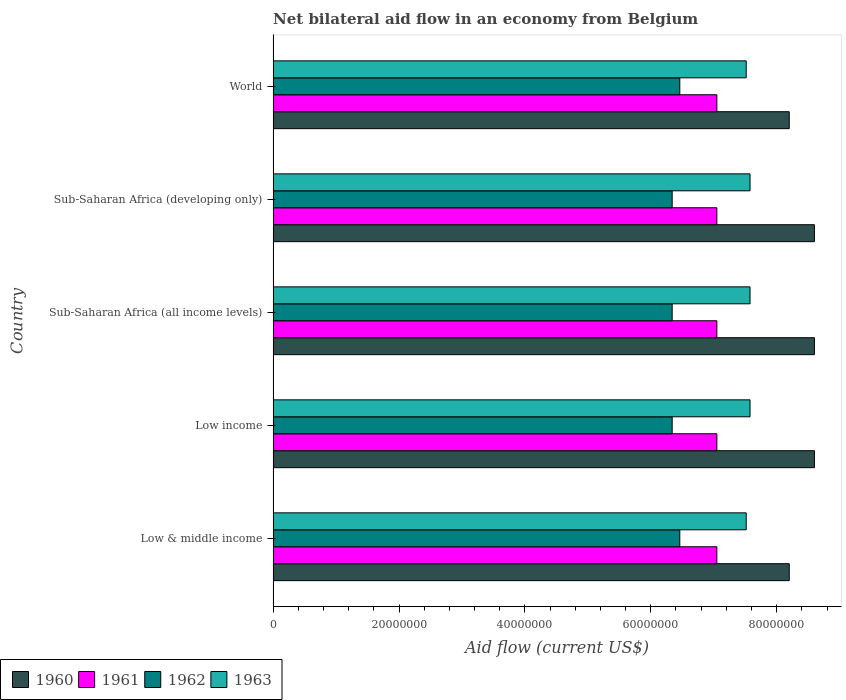How many different coloured bars are there?
Keep it short and to the point. 4. How many groups of bars are there?
Provide a short and direct response. 5. Are the number of bars on each tick of the Y-axis equal?
Give a very brief answer. Yes. How many bars are there on the 2nd tick from the top?
Offer a very short reply. 4. What is the label of the 4th group of bars from the top?
Provide a short and direct response. Low income. In how many cases, is the number of bars for a given country not equal to the number of legend labels?
Provide a succinct answer. 0. What is the net bilateral aid flow in 1960 in Sub-Saharan Africa (all income levels)?
Offer a very short reply. 8.60e+07. Across all countries, what is the maximum net bilateral aid flow in 1962?
Offer a terse response. 6.46e+07. Across all countries, what is the minimum net bilateral aid flow in 1963?
Ensure brevity in your answer.  7.52e+07. What is the total net bilateral aid flow in 1963 in the graph?
Offer a very short reply. 3.78e+08. What is the difference between the net bilateral aid flow in 1960 in Low & middle income and that in World?
Keep it short and to the point. 0. What is the difference between the net bilateral aid flow in 1960 in Low income and the net bilateral aid flow in 1961 in Low & middle income?
Offer a terse response. 1.55e+07. What is the average net bilateral aid flow in 1960 per country?
Provide a succinct answer. 8.44e+07. What is the difference between the net bilateral aid flow in 1963 and net bilateral aid flow in 1962 in Sub-Saharan Africa (all income levels)?
Ensure brevity in your answer.  1.24e+07. What is the ratio of the net bilateral aid flow in 1960 in Low & middle income to that in World?
Make the answer very short. 1. What is the difference between the highest and the lowest net bilateral aid flow in 1963?
Offer a terse response. 6.10e+05. In how many countries, is the net bilateral aid flow in 1960 greater than the average net bilateral aid flow in 1960 taken over all countries?
Provide a succinct answer. 3. What does the 2nd bar from the bottom in Low income represents?
Keep it short and to the point. 1961. Is it the case that in every country, the sum of the net bilateral aid flow in 1961 and net bilateral aid flow in 1962 is greater than the net bilateral aid flow in 1963?
Your response must be concise. Yes. How many bars are there?
Offer a terse response. 20. Does the graph contain any zero values?
Offer a very short reply. No. How many legend labels are there?
Give a very brief answer. 4. How are the legend labels stacked?
Keep it short and to the point. Horizontal. What is the title of the graph?
Give a very brief answer. Net bilateral aid flow in an economy from Belgium. What is the Aid flow (current US$) of 1960 in Low & middle income?
Provide a short and direct response. 8.20e+07. What is the Aid flow (current US$) of 1961 in Low & middle income?
Keep it short and to the point. 7.05e+07. What is the Aid flow (current US$) of 1962 in Low & middle income?
Your answer should be compact. 6.46e+07. What is the Aid flow (current US$) of 1963 in Low & middle income?
Offer a very short reply. 7.52e+07. What is the Aid flow (current US$) of 1960 in Low income?
Your answer should be very brief. 8.60e+07. What is the Aid flow (current US$) in 1961 in Low income?
Ensure brevity in your answer.  7.05e+07. What is the Aid flow (current US$) in 1962 in Low income?
Ensure brevity in your answer.  6.34e+07. What is the Aid flow (current US$) of 1963 in Low income?
Provide a short and direct response. 7.58e+07. What is the Aid flow (current US$) in 1960 in Sub-Saharan Africa (all income levels)?
Offer a very short reply. 8.60e+07. What is the Aid flow (current US$) in 1961 in Sub-Saharan Africa (all income levels)?
Your answer should be compact. 7.05e+07. What is the Aid flow (current US$) of 1962 in Sub-Saharan Africa (all income levels)?
Provide a short and direct response. 6.34e+07. What is the Aid flow (current US$) of 1963 in Sub-Saharan Africa (all income levels)?
Make the answer very short. 7.58e+07. What is the Aid flow (current US$) of 1960 in Sub-Saharan Africa (developing only)?
Give a very brief answer. 8.60e+07. What is the Aid flow (current US$) of 1961 in Sub-Saharan Africa (developing only)?
Offer a terse response. 7.05e+07. What is the Aid flow (current US$) in 1962 in Sub-Saharan Africa (developing only)?
Offer a terse response. 6.34e+07. What is the Aid flow (current US$) of 1963 in Sub-Saharan Africa (developing only)?
Ensure brevity in your answer.  7.58e+07. What is the Aid flow (current US$) of 1960 in World?
Offer a very short reply. 8.20e+07. What is the Aid flow (current US$) in 1961 in World?
Make the answer very short. 7.05e+07. What is the Aid flow (current US$) of 1962 in World?
Your answer should be very brief. 6.46e+07. What is the Aid flow (current US$) in 1963 in World?
Your answer should be compact. 7.52e+07. Across all countries, what is the maximum Aid flow (current US$) of 1960?
Your answer should be very brief. 8.60e+07. Across all countries, what is the maximum Aid flow (current US$) of 1961?
Provide a short and direct response. 7.05e+07. Across all countries, what is the maximum Aid flow (current US$) in 1962?
Ensure brevity in your answer.  6.46e+07. Across all countries, what is the maximum Aid flow (current US$) of 1963?
Provide a succinct answer. 7.58e+07. Across all countries, what is the minimum Aid flow (current US$) in 1960?
Make the answer very short. 8.20e+07. Across all countries, what is the minimum Aid flow (current US$) of 1961?
Your answer should be compact. 7.05e+07. Across all countries, what is the minimum Aid flow (current US$) of 1962?
Offer a terse response. 6.34e+07. Across all countries, what is the minimum Aid flow (current US$) of 1963?
Ensure brevity in your answer.  7.52e+07. What is the total Aid flow (current US$) of 1960 in the graph?
Give a very brief answer. 4.22e+08. What is the total Aid flow (current US$) of 1961 in the graph?
Ensure brevity in your answer.  3.52e+08. What is the total Aid flow (current US$) of 1962 in the graph?
Make the answer very short. 3.19e+08. What is the total Aid flow (current US$) of 1963 in the graph?
Offer a very short reply. 3.78e+08. What is the difference between the Aid flow (current US$) in 1960 in Low & middle income and that in Low income?
Provide a succinct answer. -4.00e+06. What is the difference between the Aid flow (current US$) of 1962 in Low & middle income and that in Low income?
Provide a short and direct response. 1.21e+06. What is the difference between the Aid flow (current US$) of 1963 in Low & middle income and that in Low income?
Your response must be concise. -6.10e+05. What is the difference between the Aid flow (current US$) of 1961 in Low & middle income and that in Sub-Saharan Africa (all income levels)?
Provide a succinct answer. 0. What is the difference between the Aid flow (current US$) in 1962 in Low & middle income and that in Sub-Saharan Africa (all income levels)?
Offer a terse response. 1.21e+06. What is the difference between the Aid flow (current US$) in 1963 in Low & middle income and that in Sub-Saharan Africa (all income levels)?
Keep it short and to the point. -6.10e+05. What is the difference between the Aid flow (current US$) in 1960 in Low & middle income and that in Sub-Saharan Africa (developing only)?
Provide a short and direct response. -4.00e+06. What is the difference between the Aid flow (current US$) of 1961 in Low & middle income and that in Sub-Saharan Africa (developing only)?
Your response must be concise. 0. What is the difference between the Aid flow (current US$) of 1962 in Low & middle income and that in Sub-Saharan Africa (developing only)?
Keep it short and to the point. 1.21e+06. What is the difference between the Aid flow (current US$) of 1963 in Low & middle income and that in Sub-Saharan Africa (developing only)?
Provide a short and direct response. -6.10e+05. What is the difference between the Aid flow (current US$) of 1960 in Low & middle income and that in World?
Keep it short and to the point. 0. What is the difference between the Aid flow (current US$) of 1962 in Low & middle income and that in World?
Give a very brief answer. 0. What is the difference between the Aid flow (current US$) in 1961 in Low income and that in Sub-Saharan Africa (all income levels)?
Make the answer very short. 0. What is the difference between the Aid flow (current US$) in 1963 in Low income and that in Sub-Saharan Africa (all income levels)?
Offer a very short reply. 0. What is the difference between the Aid flow (current US$) in 1962 in Low income and that in World?
Provide a short and direct response. -1.21e+06. What is the difference between the Aid flow (current US$) in 1963 in Low income and that in World?
Provide a short and direct response. 6.10e+05. What is the difference between the Aid flow (current US$) of 1960 in Sub-Saharan Africa (all income levels) and that in Sub-Saharan Africa (developing only)?
Your response must be concise. 0. What is the difference between the Aid flow (current US$) in 1961 in Sub-Saharan Africa (all income levels) and that in Sub-Saharan Africa (developing only)?
Offer a very short reply. 0. What is the difference between the Aid flow (current US$) in 1963 in Sub-Saharan Africa (all income levels) and that in Sub-Saharan Africa (developing only)?
Your response must be concise. 0. What is the difference between the Aid flow (current US$) in 1961 in Sub-Saharan Africa (all income levels) and that in World?
Give a very brief answer. 0. What is the difference between the Aid flow (current US$) of 1962 in Sub-Saharan Africa (all income levels) and that in World?
Offer a very short reply. -1.21e+06. What is the difference between the Aid flow (current US$) of 1963 in Sub-Saharan Africa (all income levels) and that in World?
Your answer should be very brief. 6.10e+05. What is the difference between the Aid flow (current US$) in 1962 in Sub-Saharan Africa (developing only) and that in World?
Make the answer very short. -1.21e+06. What is the difference between the Aid flow (current US$) in 1963 in Sub-Saharan Africa (developing only) and that in World?
Provide a short and direct response. 6.10e+05. What is the difference between the Aid flow (current US$) in 1960 in Low & middle income and the Aid flow (current US$) in 1961 in Low income?
Provide a succinct answer. 1.15e+07. What is the difference between the Aid flow (current US$) in 1960 in Low & middle income and the Aid flow (current US$) in 1962 in Low income?
Make the answer very short. 1.86e+07. What is the difference between the Aid flow (current US$) of 1960 in Low & middle income and the Aid flow (current US$) of 1963 in Low income?
Your response must be concise. 6.23e+06. What is the difference between the Aid flow (current US$) in 1961 in Low & middle income and the Aid flow (current US$) in 1962 in Low income?
Your answer should be compact. 7.10e+06. What is the difference between the Aid flow (current US$) of 1961 in Low & middle income and the Aid flow (current US$) of 1963 in Low income?
Offer a very short reply. -5.27e+06. What is the difference between the Aid flow (current US$) in 1962 in Low & middle income and the Aid flow (current US$) in 1963 in Low income?
Your answer should be very brief. -1.12e+07. What is the difference between the Aid flow (current US$) in 1960 in Low & middle income and the Aid flow (current US$) in 1961 in Sub-Saharan Africa (all income levels)?
Give a very brief answer. 1.15e+07. What is the difference between the Aid flow (current US$) in 1960 in Low & middle income and the Aid flow (current US$) in 1962 in Sub-Saharan Africa (all income levels)?
Provide a succinct answer. 1.86e+07. What is the difference between the Aid flow (current US$) in 1960 in Low & middle income and the Aid flow (current US$) in 1963 in Sub-Saharan Africa (all income levels)?
Keep it short and to the point. 6.23e+06. What is the difference between the Aid flow (current US$) in 1961 in Low & middle income and the Aid flow (current US$) in 1962 in Sub-Saharan Africa (all income levels)?
Provide a succinct answer. 7.10e+06. What is the difference between the Aid flow (current US$) of 1961 in Low & middle income and the Aid flow (current US$) of 1963 in Sub-Saharan Africa (all income levels)?
Keep it short and to the point. -5.27e+06. What is the difference between the Aid flow (current US$) in 1962 in Low & middle income and the Aid flow (current US$) in 1963 in Sub-Saharan Africa (all income levels)?
Ensure brevity in your answer.  -1.12e+07. What is the difference between the Aid flow (current US$) of 1960 in Low & middle income and the Aid flow (current US$) of 1961 in Sub-Saharan Africa (developing only)?
Your answer should be compact. 1.15e+07. What is the difference between the Aid flow (current US$) of 1960 in Low & middle income and the Aid flow (current US$) of 1962 in Sub-Saharan Africa (developing only)?
Give a very brief answer. 1.86e+07. What is the difference between the Aid flow (current US$) of 1960 in Low & middle income and the Aid flow (current US$) of 1963 in Sub-Saharan Africa (developing only)?
Keep it short and to the point. 6.23e+06. What is the difference between the Aid flow (current US$) in 1961 in Low & middle income and the Aid flow (current US$) in 1962 in Sub-Saharan Africa (developing only)?
Keep it short and to the point. 7.10e+06. What is the difference between the Aid flow (current US$) in 1961 in Low & middle income and the Aid flow (current US$) in 1963 in Sub-Saharan Africa (developing only)?
Your answer should be compact. -5.27e+06. What is the difference between the Aid flow (current US$) in 1962 in Low & middle income and the Aid flow (current US$) in 1963 in Sub-Saharan Africa (developing only)?
Offer a very short reply. -1.12e+07. What is the difference between the Aid flow (current US$) in 1960 in Low & middle income and the Aid flow (current US$) in 1961 in World?
Provide a short and direct response. 1.15e+07. What is the difference between the Aid flow (current US$) of 1960 in Low & middle income and the Aid flow (current US$) of 1962 in World?
Provide a succinct answer. 1.74e+07. What is the difference between the Aid flow (current US$) in 1960 in Low & middle income and the Aid flow (current US$) in 1963 in World?
Provide a short and direct response. 6.84e+06. What is the difference between the Aid flow (current US$) of 1961 in Low & middle income and the Aid flow (current US$) of 1962 in World?
Your answer should be compact. 5.89e+06. What is the difference between the Aid flow (current US$) in 1961 in Low & middle income and the Aid flow (current US$) in 1963 in World?
Keep it short and to the point. -4.66e+06. What is the difference between the Aid flow (current US$) of 1962 in Low & middle income and the Aid flow (current US$) of 1963 in World?
Your answer should be very brief. -1.06e+07. What is the difference between the Aid flow (current US$) of 1960 in Low income and the Aid flow (current US$) of 1961 in Sub-Saharan Africa (all income levels)?
Keep it short and to the point. 1.55e+07. What is the difference between the Aid flow (current US$) in 1960 in Low income and the Aid flow (current US$) in 1962 in Sub-Saharan Africa (all income levels)?
Provide a short and direct response. 2.26e+07. What is the difference between the Aid flow (current US$) of 1960 in Low income and the Aid flow (current US$) of 1963 in Sub-Saharan Africa (all income levels)?
Your response must be concise. 1.02e+07. What is the difference between the Aid flow (current US$) in 1961 in Low income and the Aid flow (current US$) in 1962 in Sub-Saharan Africa (all income levels)?
Your answer should be very brief. 7.10e+06. What is the difference between the Aid flow (current US$) of 1961 in Low income and the Aid flow (current US$) of 1963 in Sub-Saharan Africa (all income levels)?
Your answer should be very brief. -5.27e+06. What is the difference between the Aid flow (current US$) in 1962 in Low income and the Aid flow (current US$) in 1963 in Sub-Saharan Africa (all income levels)?
Provide a succinct answer. -1.24e+07. What is the difference between the Aid flow (current US$) in 1960 in Low income and the Aid flow (current US$) in 1961 in Sub-Saharan Africa (developing only)?
Keep it short and to the point. 1.55e+07. What is the difference between the Aid flow (current US$) of 1960 in Low income and the Aid flow (current US$) of 1962 in Sub-Saharan Africa (developing only)?
Provide a short and direct response. 2.26e+07. What is the difference between the Aid flow (current US$) in 1960 in Low income and the Aid flow (current US$) in 1963 in Sub-Saharan Africa (developing only)?
Your response must be concise. 1.02e+07. What is the difference between the Aid flow (current US$) of 1961 in Low income and the Aid flow (current US$) of 1962 in Sub-Saharan Africa (developing only)?
Give a very brief answer. 7.10e+06. What is the difference between the Aid flow (current US$) of 1961 in Low income and the Aid flow (current US$) of 1963 in Sub-Saharan Africa (developing only)?
Provide a short and direct response. -5.27e+06. What is the difference between the Aid flow (current US$) in 1962 in Low income and the Aid flow (current US$) in 1963 in Sub-Saharan Africa (developing only)?
Your answer should be compact. -1.24e+07. What is the difference between the Aid flow (current US$) in 1960 in Low income and the Aid flow (current US$) in 1961 in World?
Provide a short and direct response. 1.55e+07. What is the difference between the Aid flow (current US$) of 1960 in Low income and the Aid flow (current US$) of 1962 in World?
Provide a succinct answer. 2.14e+07. What is the difference between the Aid flow (current US$) in 1960 in Low income and the Aid flow (current US$) in 1963 in World?
Ensure brevity in your answer.  1.08e+07. What is the difference between the Aid flow (current US$) of 1961 in Low income and the Aid flow (current US$) of 1962 in World?
Your response must be concise. 5.89e+06. What is the difference between the Aid flow (current US$) of 1961 in Low income and the Aid flow (current US$) of 1963 in World?
Ensure brevity in your answer.  -4.66e+06. What is the difference between the Aid flow (current US$) in 1962 in Low income and the Aid flow (current US$) in 1963 in World?
Provide a succinct answer. -1.18e+07. What is the difference between the Aid flow (current US$) in 1960 in Sub-Saharan Africa (all income levels) and the Aid flow (current US$) in 1961 in Sub-Saharan Africa (developing only)?
Make the answer very short. 1.55e+07. What is the difference between the Aid flow (current US$) in 1960 in Sub-Saharan Africa (all income levels) and the Aid flow (current US$) in 1962 in Sub-Saharan Africa (developing only)?
Provide a succinct answer. 2.26e+07. What is the difference between the Aid flow (current US$) of 1960 in Sub-Saharan Africa (all income levels) and the Aid flow (current US$) of 1963 in Sub-Saharan Africa (developing only)?
Provide a short and direct response. 1.02e+07. What is the difference between the Aid flow (current US$) in 1961 in Sub-Saharan Africa (all income levels) and the Aid flow (current US$) in 1962 in Sub-Saharan Africa (developing only)?
Offer a very short reply. 7.10e+06. What is the difference between the Aid flow (current US$) of 1961 in Sub-Saharan Africa (all income levels) and the Aid flow (current US$) of 1963 in Sub-Saharan Africa (developing only)?
Provide a short and direct response. -5.27e+06. What is the difference between the Aid flow (current US$) in 1962 in Sub-Saharan Africa (all income levels) and the Aid flow (current US$) in 1963 in Sub-Saharan Africa (developing only)?
Provide a succinct answer. -1.24e+07. What is the difference between the Aid flow (current US$) of 1960 in Sub-Saharan Africa (all income levels) and the Aid flow (current US$) of 1961 in World?
Keep it short and to the point. 1.55e+07. What is the difference between the Aid flow (current US$) in 1960 in Sub-Saharan Africa (all income levels) and the Aid flow (current US$) in 1962 in World?
Make the answer very short. 2.14e+07. What is the difference between the Aid flow (current US$) in 1960 in Sub-Saharan Africa (all income levels) and the Aid flow (current US$) in 1963 in World?
Make the answer very short. 1.08e+07. What is the difference between the Aid flow (current US$) in 1961 in Sub-Saharan Africa (all income levels) and the Aid flow (current US$) in 1962 in World?
Keep it short and to the point. 5.89e+06. What is the difference between the Aid flow (current US$) in 1961 in Sub-Saharan Africa (all income levels) and the Aid flow (current US$) in 1963 in World?
Keep it short and to the point. -4.66e+06. What is the difference between the Aid flow (current US$) of 1962 in Sub-Saharan Africa (all income levels) and the Aid flow (current US$) of 1963 in World?
Provide a short and direct response. -1.18e+07. What is the difference between the Aid flow (current US$) in 1960 in Sub-Saharan Africa (developing only) and the Aid flow (current US$) in 1961 in World?
Give a very brief answer. 1.55e+07. What is the difference between the Aid flow (current US$) of 1960 in Sub-Saharan Africa (developing only) and the Aid flow (current US$) of 1962 in World?
Your response must be concise. 2.14e+07. What is the difference between the Aid flow (current US$) in 1960 in Sub-Saharan Africa (developing only) and the Aid flow (current US$) in 1963 in World?
Provide a succinct answer. 1.08e+07. What is the difference between the Aid flow (current US$) of 1961 in Sub-Saharan Africa (developing only) and the Aid flow (current US$) of 1962 in World?
Give a very brief answer. 5.89e+06. What is the difference between the Aid flow (current US$) of 1961 in Sub-Saharan Africa (developing only) and the Aid flow (current US$) of 1963 in World?
Provide a succinct answer. -4.66e+06. What is the difference between the Aid flow (current US$) in 1962 in Sub-Saharan Africa (developing only) and the Aid flow (current US$) in 1963 in World?
Your answer should be very brief. -1.18e+07. What is the average Aid flow (current US$) of 1960 per country?
Keep it short and to the point. 8.44e+07. What is the average Aid flow (current US$) in 1961 per country?
Your answer should be very brief. 7.05e+07. What is the average Aid flow (current US$) of 1962 per country?
Offer a terse response. 6.39e+07. What is the average Aid flow (current US$) of 1963 per country?
Provide a short and direct response. 7.55e+07. What is the difference between the Aid flow (current US$) of 1960 and Aid flow (current US$) of 1961 in Low & middle income?
Offer a terse response. 1.15e+07. What is the difference between the Aid flow (current US$) of 1960 and Aid flow (current US$) of 1962 in Low & middle income?
Provide a succinct answer. 1.74e+07. What is the difference between the Aid flow (current US$) in 1960 and Aid flow (current US$) in 1963 in Low & middle income?
Offer a terse response. 6.84e+06. What is the difference between the Aid flow (current US$) of 1961 and Aid flow (current US$) of 1962 in Low & middle income?
Keep it short and to the point. 5.89e+06. What is the difference between the Aid flow (current US$) in 1961 and Aid flow (current US$) in 1963 in Low & middle income?
Give a very brief answer. -4.66e+06. What is the difference between the Aid flow (current US$) in 1962 and Aid flow (current US$) in 1963 in Low & middle income?
Make the answer very short. -1.06e+07. What is the difference between the Aid flow (current US$) of 1960 and Aid flow (current US$) of 1961 in Low income?
Your answer should be compact. 1.55e+07. What is the difference between the Aid flow (current US$) of 1960 and Aid flow (current US$) of 1962 in Low income?
Make the answer very short. 2.26e+07. What is the difference between the Aid flow (current US$) of 1960 and Aid flow (current US$) of 1963 in Low income?
Your answer should be compact. 1.02e+07. What is the difference between the Aid flow (current US$) in 1961 and Aid flow (current US$) in 1962 in Low income?
Provide a succinct answer. 7.10e+06. What is the difference between the Aid flow (current US$) of 1961 and Aid flow (current US$) of 1963 in Low income?
Your response must be concise. -5.27e+06. What is the difference between the Aid flow (current US$) in 1962 and Aid flow (current US$) in 1963 in Low income?
Offer a very short reply. -1.24e+07. What is the difference between the Aid flow (current US$) in 1960 and Aid flow (current US$) in 1961 in Sub-Saharan Africa (all income levels)?
Your answer should be very brief. 1.55e+07. What is the difference between the Aid flow (current US$) of 1960 and Aid flow (current US$) of 1962 in Sub-Saharan Africa (all income levels)?
Your answer should be compact. 2.26e+07. What is the difference between the Aid flow (current US$) of 1960 and Aid flow (current US$) of 1963 in Sub-Saharan Africa (all income levels)?
Keep it short and to the point. 1.02e+07. What is the difference between the Aid flow (current US$) of 1961 and Aid flow (current US$) of 1962 in Sub-Saharan Africa (all income levels)?
Your response must be concise. 7.10e+06. What is the difference between the Aid flow (current US$) in 1961 and Aid flow (current US$) in 1963 in Sub-Saharan Africa (all income levels)?
Keep it short and to the point. -5.27e+06. What is the difference between the Aid flow (current US$) of 1962 and Aid flow (current US$) of 1963 in Sub-Saharan Africa (all income levels)?
Offer a terse response. -1.24e+07. What is the difference between the Aid flow (current US$) of 1960 and Aid flow (current US$) of 1961 in Sub-Saharan Africa (developing only)?
Your answer should be compact. 1.55e+07. What is the difference between the Aid flow (current US$) in 1960 and Aid flow (current US$) in 1962 in Sub-Saharan Africa (developing only)?
Provide a succinct answer. 2.26e+07. What is the difference between the Aid flow (current US$) of 1960 and Aid flow (current US$) of 1963 in Sub-Saharan Africa (developing only)?
Provide a succinct answer. 1.02e+07. What is the difference between the Aid flow (current US$) in 1961 and Aid flow (current US$) in 1962 in Sub-Saharan Africa (developing only)?
Keep it short and to the point. 7.10e+06. What is the difference between the Aid flow (current US$) in 1961 and Aid flow (current US$) in 1963 in Sub-Saharan Africa (developing only)?
Your answer should be compact. -5.27e+06. What is the difference between the Aid flow (current US$) in 1962 and Aid flow (current US$) in 1963 in Sub-Saharan Africa (developing only)?
Provide a short and direct response. -1.24e+07. What is the difference between the Aid flow (current US$) of 1960 and Aid flow (current US$) of 1961 in World?
Your response must be concise. 1.15e+07. What is the difference between the Aid flow (current US$) in 1960 and Aid flow (current US$) in 1962 in World?
Make the answer very short. 1.74e+07. What is the difference between the Aid flow (current US$) of 1960 and Aid flow (current US$) of 1963 in World?
Make the answer very short. 6.84e+06. What is the difference between the Aid flow (current US$) in 1961 and Aid flow (current US$) in 1962 in World?
Provide a succinct answer. 5.89e+06. What is the difference between the Aid flow (current US$) in 1961 and Aid flow (current US$) in 1963 in World?
Provide a succinct answer. -4.66e+06. What is the difference between the Aid flow (current US$) of 1962 and Aid flow (current US$) of 1963 in World?
Ensure brevity in your answer.  -1.06e+07. What is the ratio of the Aid flow (current US$) in 1960 in Low & middle income to that in Low income?
Offer a very short reply. 0.95. What is the ratio of the Aid flow (current US$) of 1961 in Low & middle income to that in Low income?
Make the answer very short. 1. What is the ratio of the Aid flow (current US$) in 1962 in Low & middle income to that in Low income?
Provide a short and direct response. 1.02. What is the ratio of the Aid flow (current US$) in 1960 in Low & middle income to that in Sub-Saharan Africa (all income levels)?
Make the answer very short. 0.95. What is the ratio of the Aid flow (current US$) in 1961 in Low & middle income to that in Sub-Saharan Africa (all income levels)?
Your answer should be compact. 1. What is the ratio of the Aid flow (current US$) of 1962 in Low & middle income to that in Sub-Saharan Africa (all income levels)?
Make the answer very short. 1.02. What is the ratio of the Aid flow (current US$) in 1960 in Low & middle income to that in Sub-Saharan Africa (developing only)?
Your response must be concise. 0.95. What is the ratio of the Aid flow (current US$) of 1962 in Low & middle income to that in Sub-Saharan Africa (developing only)?
Provide a succinct answer. 1.02. What is the ratio of the Aid flow (current US$) in 1960 in Low & middle income to that in World?
Offer a very short reply. 1. What is the ratio of the Aid flow (current US$) in 1962 in Low & middle income to that in World?
Ensure brevity in your answer.  1. What is the ratio of the Aid flow (current US$) in 1963 in Low & middle income to that in World?
Keep it short and to the point. 1. What is the ratio of the Aid flow (current US$) in 1963 in Low income to that in Sub-Saharan Africa (all income levels)?
Provide a short and direct response. 1. What is the ratio of the Aid flow (current US$) in 1960 in Low income to that in Sub-Saharan Africa (developing only)?
Ensure brevity in your answer.  1. What is the ratio of the Aid flow (current US$) in 1961 in Low income to that in Sub-Saharan Africa (developing only)?
Keep it short and to the point. 1. What is the ratio of the Aid flow (current US$) in 1960 in Low income to that in World?
Give a very brief answer. 1.05. What is the ratio of the Aid flow (current US$) in 1961 in Low income to that in World?
Offer a terse response. 1. What is the ratio of the Aid flow (current US$) in 1962 in Low income to that in World?
Ensure brevity in your answer.  0.98. What is the ratio of the Aid flow (current US$) in 1963 in Low income to that in World?
Ensure brevity in your answer.  1.01. What is the ratio of the Aid flow (current US$) in 1961 in Sub-Saharan Africa (all income levels) to that in Sub-Saharan Africa (developing only)?
Your response must be concise. 1. What is the ratio of the Aid flow (current US$) of 1962 in Sub-Saharan Africa (all income levels) to that in Sub-Saharan Africa (developing only)?
Offer a very short reply. 1. What is the ratio of the Aid flow (current US$) in 1960 in Sub-Saharan Africa (all income levels) to that in World?
Offer a very short reply. 1.05. What is the ratio of the Aid flow (current US$) of 1961 in Sub-Saharan Africa (all income levels) to that in World?
Give a very brief answer. 1. What is the ratio of the Aid flow (current US$) of 1962 in Sub-Saharan Africa (all income levels) to that in World?
Provide a succinct answer. 0.98. What is the ratio of the Aid flow (current US$) in 1963 in Sub-Saharan Africa (all income levels) to that in World?
Ensure brevity in your answer.  1.01. What is the ratio of the Aid flow (current US$) of 1960 in Sub-Saharan Africa (developing only) to that in World?
Make the answer very short. 1.05. What is the ratio of the Aid flow (current US$) of 1961 in Sub-Saharan Africa (developing only) to that in World?
Make the answer very short. 1. What is the ratio of the Aid flow (current US$) in 1962 in Sub-Saharan Africa (developing only) to that in World?
Keep it short and to the point. 0.98. What is the difference between the highest and the second highest Aid flow (current US$) of 1960?
Your answer should be very brief. 0. What is the difference between the highest and the second highest Aid flow (current US$) in 1963?
Give a very brief answer. 0. What is the difference between the highest and the lowest Aid flow (current US$) in 1960?
Provide a short and direct response. 4.00e+06. What is the difference between the highest and the lowest Aid flow (current US$) of 1961?
Ensure brevity in your answer.  0. What is the difference between the highest and the lowest Aid flow (current US$) of 1962?
Keep it short and to the point. 1.21e+06. 